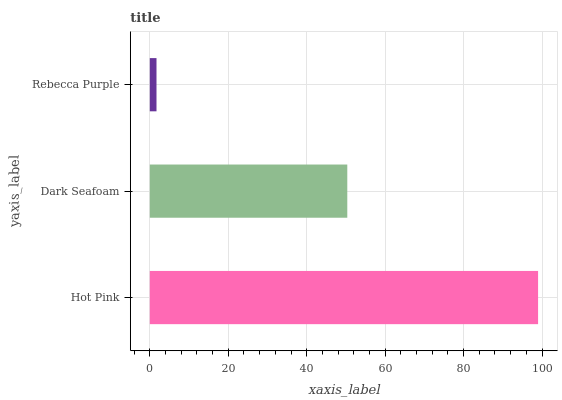Is Rebecca Purple the minimum?
Answer yes or no. Yes. Is Hot Pink the maximum?
Answer yes or no. Yes. Is Dark Seafoam the minimum?
Answer yes or no. No. Is Dark Seafoam the maximum?
Answer yes or no. No. Is Hot Pink greater than Dark Seafoam?
Answer yes or no. Yes. Is Dark Seafoam less than Hot Pink?
Answer yes or no. Yes. Is Dark Seafoam greater than Hot Pink?
Answer yes or no. No. Is Hot Pink less than Dark Seafoam?
Answer yes or no. No. Is Dark Seafoam the high median?
Answer yes or no. Yes. Is Dark Seafoam the low median?
Answer yes or no. Yes. Is Rebecca Purple the high median?
Answer yes or no. No. Is Rebecca Purple the low median?
Answer yes or no. No. 